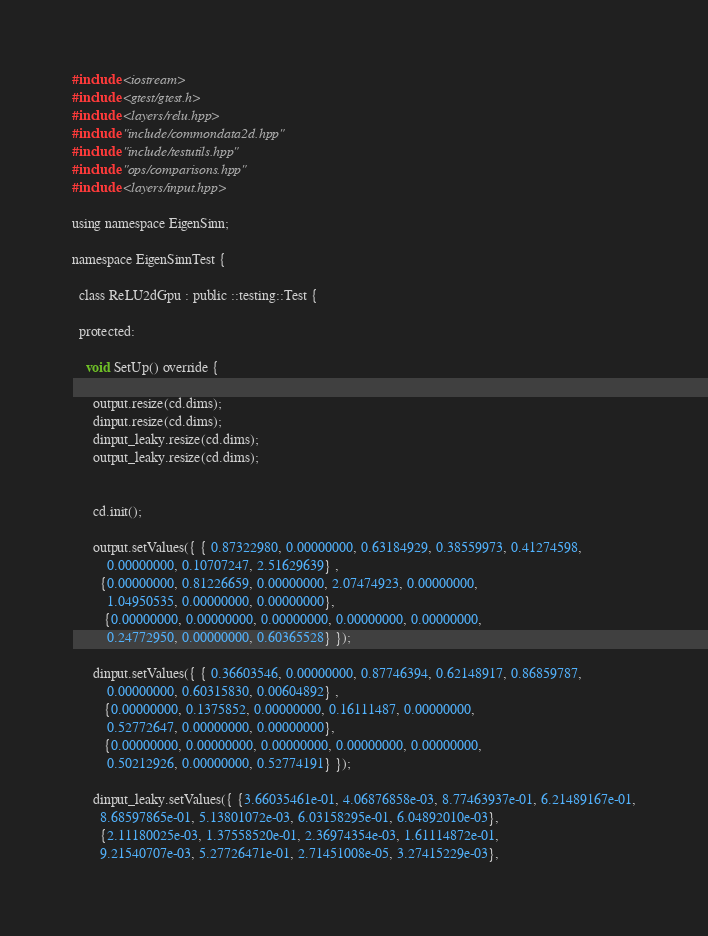Convert code to text. <code><loc_0><loc_0><loc_500><loc_500><_Cuda_>#include <iostream>
#include <gtest/gtest.h>
#include <layers/relu.hpp>
#include "include/commondata2d.hpp"
#include "include/testutils.hpp"
#include "ops/comparisons.hpp"
#include <layers/input.hpp>

using namespace EigenSinn;

namespace EigenSinnTest {

  class ReLU2dGpu : public ::testing::Test {

  protected:

    void SetUp() override {

      output.resize(cd.dims);
      dinput.resize(cd.dims);
      dinput_leaky.resize(cd.dims);
      output_leaky.resize(cd.dims);
      

      cd.init();

      output.setValues({ { 0.87322980, 0.00000000, 0.63184929, 0.38559973, 0.41274598,
          0.00000000, 0.10707247, 2.51629639} ,
        {0.00000000, 0.81226659, 0.00000000, 2.07474923, 0.00000000,
          1.04950535, 0.00000000, 0.00000000},
         {0.00000000, 0.00000000, 0.00000000, 0.00000000, 0.00000000,
          0.24772950, 0.00000000, 0.60365528} });

      dinput.setValues({ { 0.36603546, 0.00000000, 0.87746394, 0.62148917, 0.86859787,
          0.00000000, 0.60315830, 0.00604892} ,
         {0.00000000, 0.1375852, 0.00000000, 0.16111487, 0.00000000,
          0.52772647, 0.00000000, 0.00000000},
         {0.00000000, 0.00000000, 0.00000000, 0.00000000, 0.00000000,
          0.50212926, 0.00000000, 0.52774191} });

      dinput_leaky.setValues({ {3.66035461e-01, 4.06876858e-03, 8.77463937e-01, 6.21489167e-01,
        8.68597865e-01, 5.13801072e-03, 6.03158295e-01, 6.04892010e-03},
        {2.11180025e-03, 1.37558520e-01, 2.36974354e-03, 1.61114872e-01,
        9.21540707e-03, 5.27726471e-01, 2.71451008e-05, 3.27415229e-03},</code> 